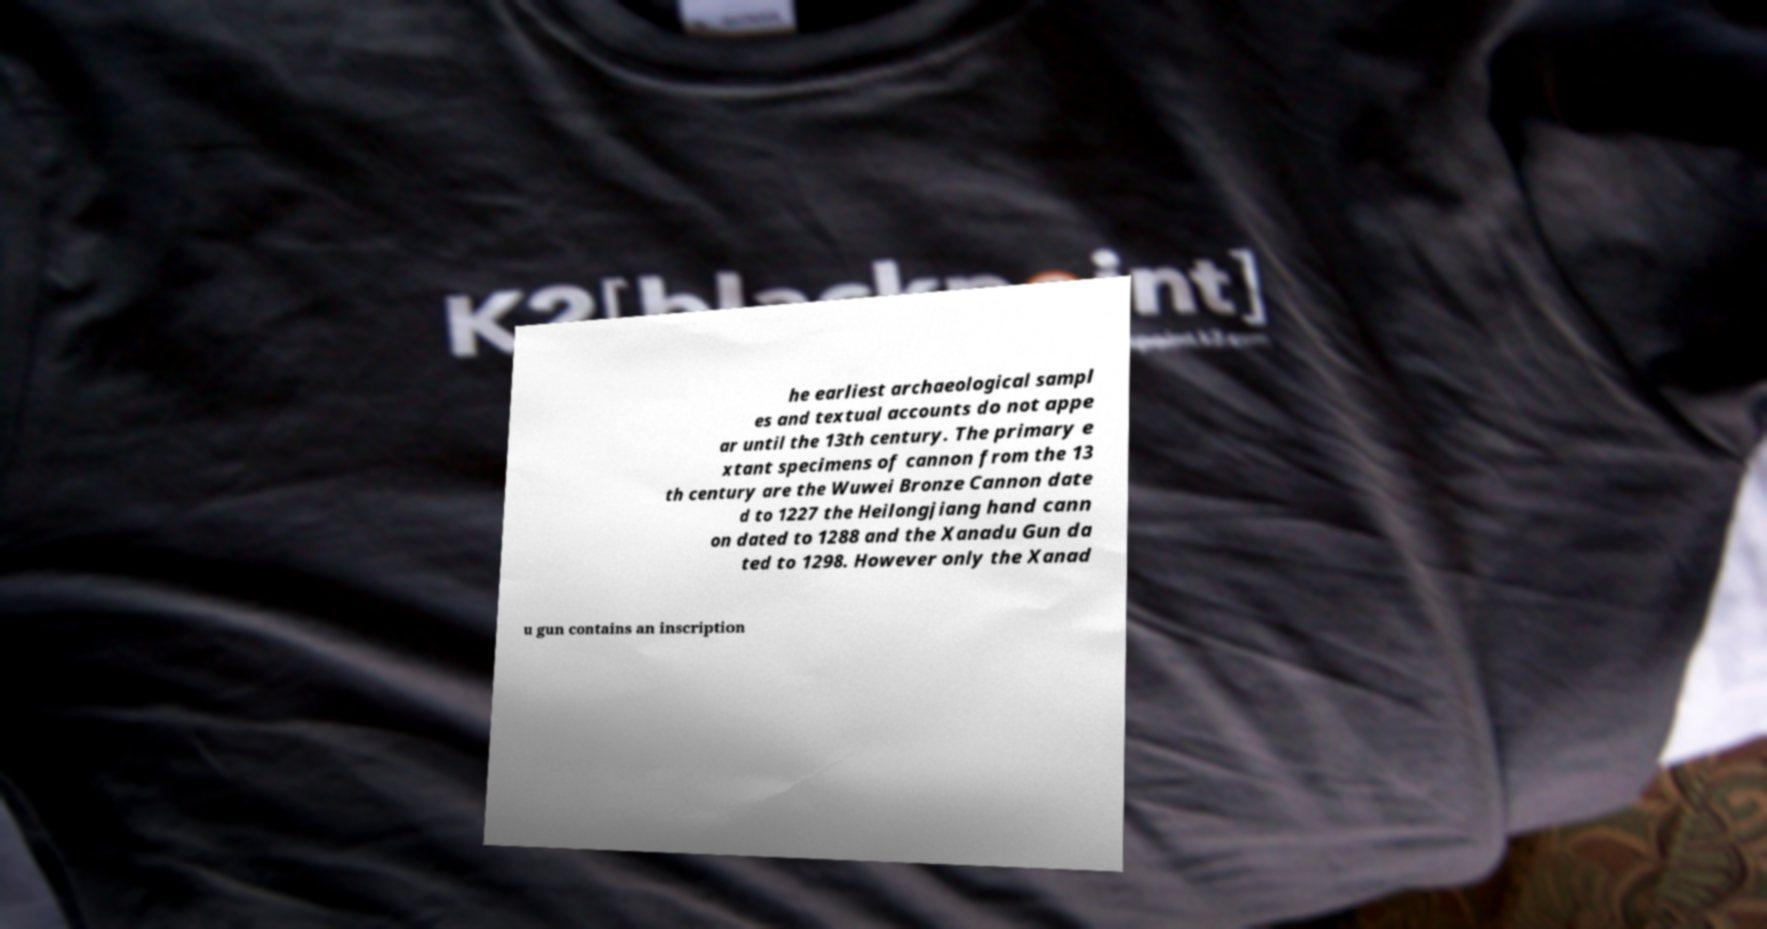Could you assist in decoding the text presented in this image and type it out clearly? he earliest archaeological sampl es and textual accounts do not appe ar until the 13th century. The primary e xtant specimens of cannon from the 13 th century are the Wuwei Bronze Cannon date d to 1227 the Heilongjiang hand cann on dated to 1288 and the Xanadu Gun da ted to 1298. However only the Xanad u gun contains an inscription 